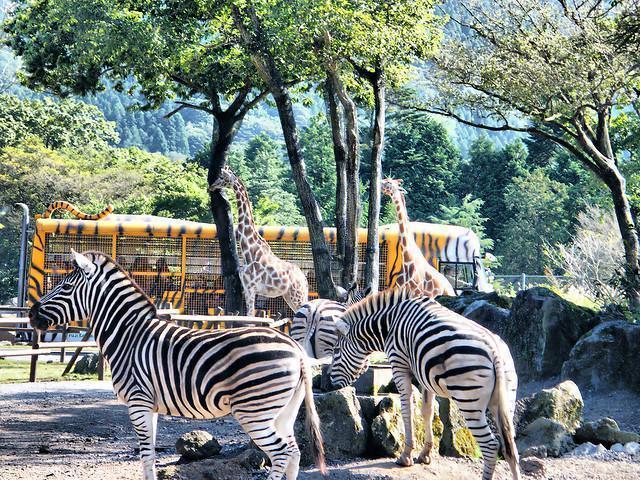What kind of vehicle is the yellow thing?
Select the correct answer and articulate reasoning with the following format: 'Answer: answer
Rationale: rationale.'
Options: Tour bus, truck, school bus, train. Answer: tour bus.
Rationale: It is a non-tracked road vehicle that is designed to carry passengers. the vehicle is at a zoo and has an animal-themed livery, so it is used by people visiting the zoo. 